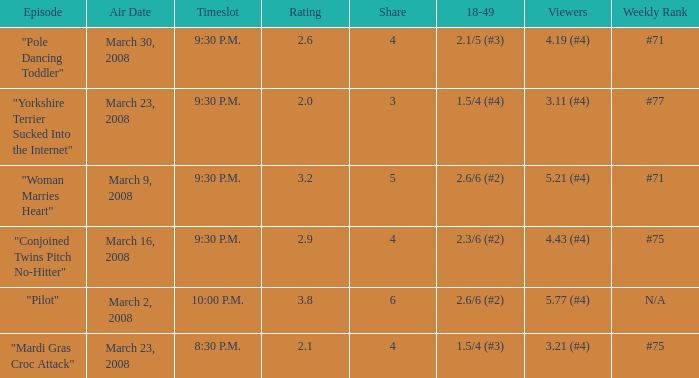What is the total ratings on share less than 4? 1.0. 